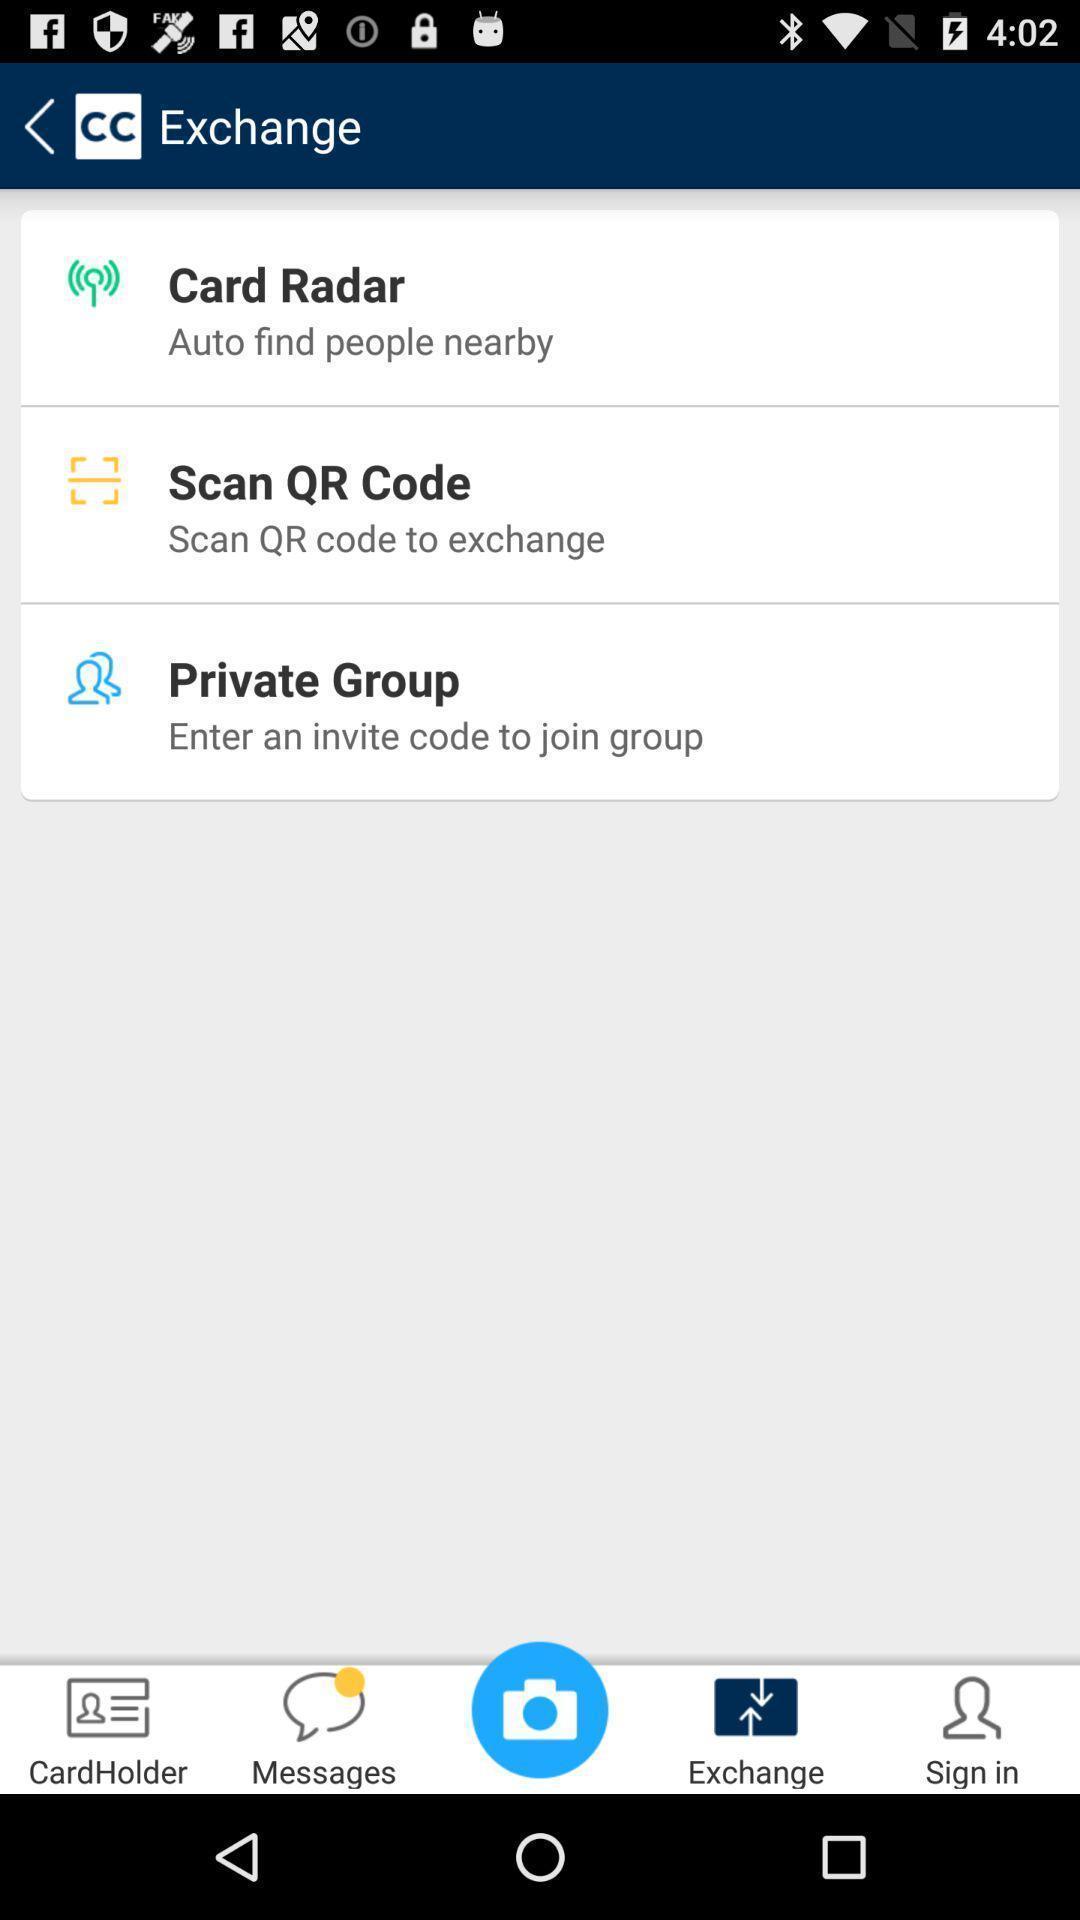Give me a narrative description of this picture. Screen showing exchange options. Explain the elements present in this screenshot. Screen showing number of options. 